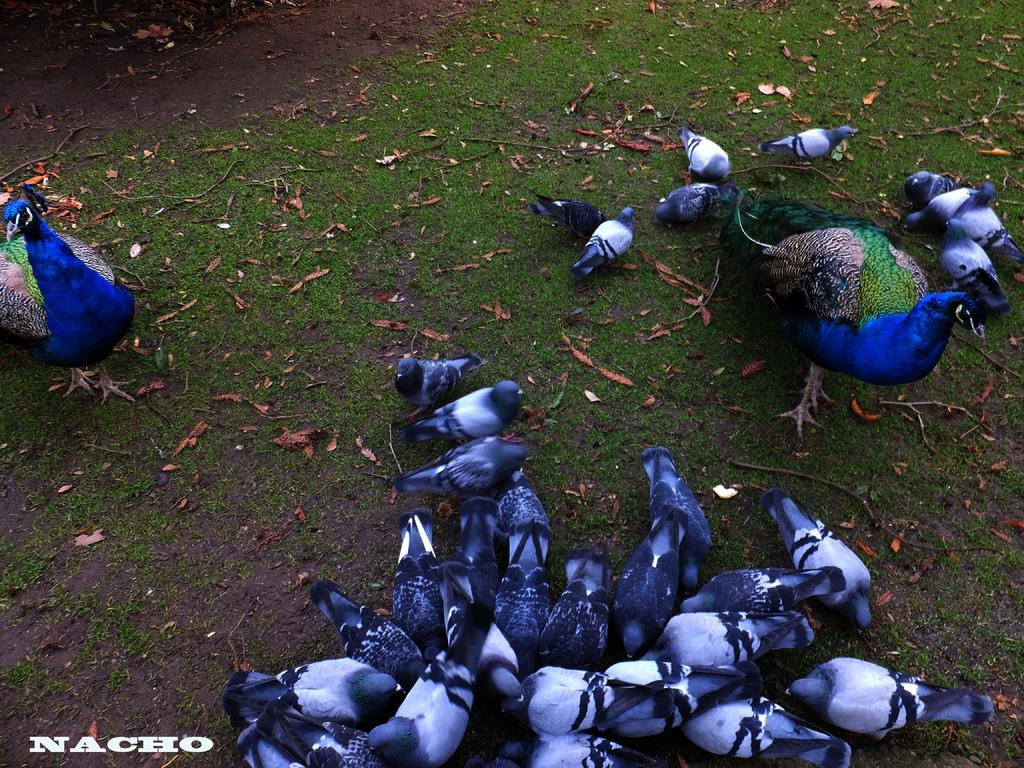What type of animals are in the foreground of the picture? There are birds and peacocks in the foreground of the picture. What are the birds and peacocks standing on? The birds and peacocks are on the grass. What part of the ground can be seen in the image? The ground is visible at the top of the image. How many jellyfish can be seen swimming in the grass in the image? There are no jellyfish present in the image, and jellyfish cannot swim on grass. 